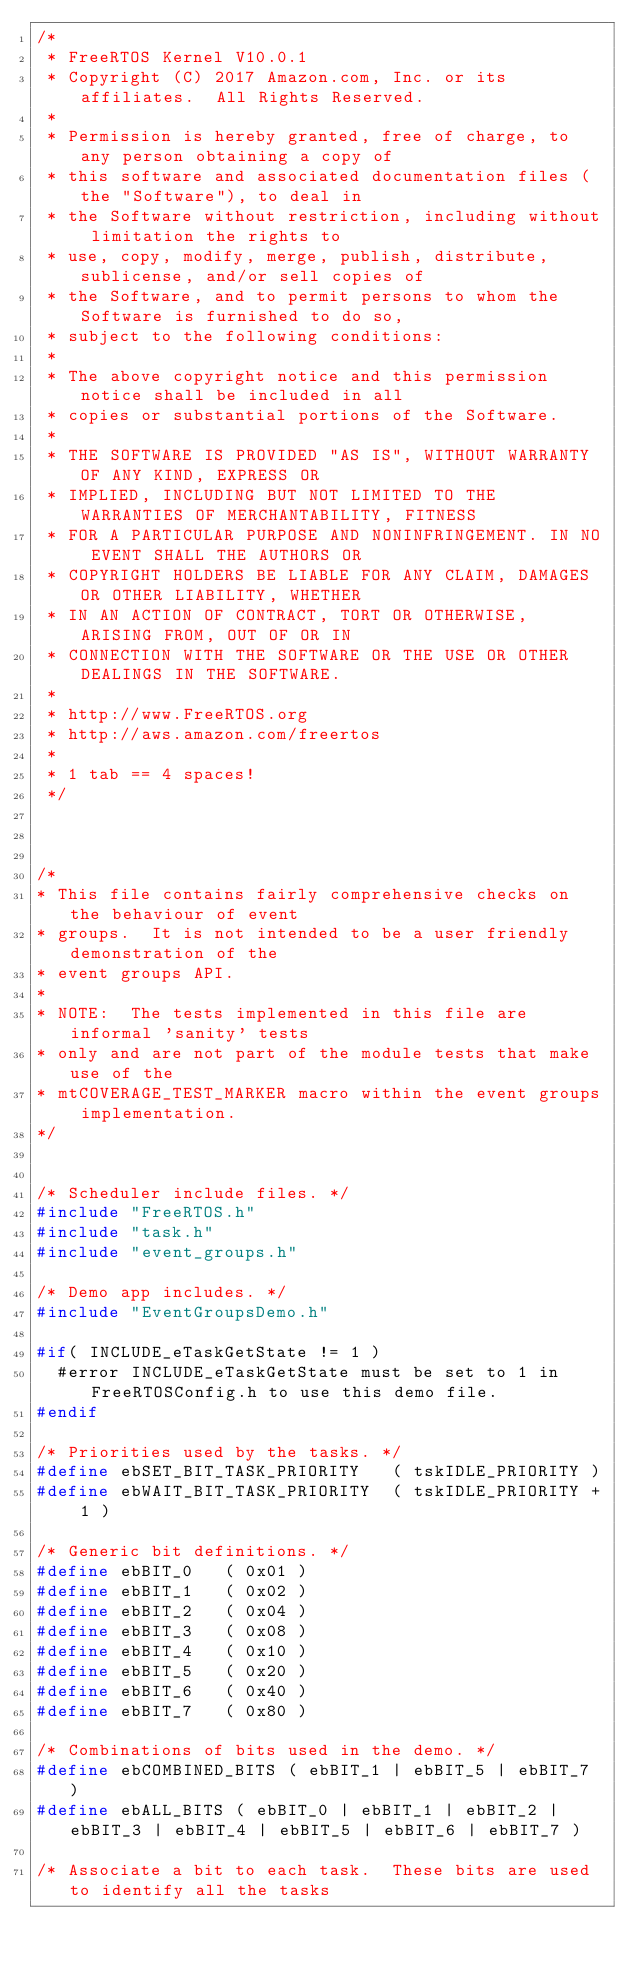Convert code to text. <code><loc_0><loc_0><loc_500><loc_500><_C_>/*
 * FreeRTOS Kernel V10.0.1
 * Copyright (C) 2017 Amazon.com, Inc. or its affiliates.  All Rights Reserved.
 *
 * Permission is hereby granted, free of charge, to any person obtaining a copy of
 * this software and associated documentation files (the "Software"), to deal in
 * the Software without restriction, including without limitation the rights to
 * use, copy, modify, merge, publish, distribute, sublicense, and/or sell copies of
 * the Software, and to permit persons to whom the Software is furnished to do so,
 * subject to the following conditions:
 *
 * The above copyright notice and this permission notice shall be included in all
 * copies or substantial portions of the Software.
 *
 * THE SOFTWARE IS PROVIDED "AS IS", WITHOUT WARRANTY OF ANY KIND, EXPRESS OR
 * IMPLIED, INCLUDING BUT NOT LIMITED TO THE WARRANTIES OF MERCHANTABILITY, FITNESS
 * FOR A PARTICULAR PURPOSE AND NONINFRINGEMENT. IN NO EVENT SHALL THE AUTHORS OR
 * COPYRIGHT HOLDERS BE LIABLE FOR ANY CLAIM, DAMAGES OR OTHER LIABILITY, WHETHER
 * IN AN ACTION OF CONTRACT, TORT OR OTHERWISE, ARISING FROM, OUT OF OR IN
 * CONNECTION WITH THE SOFTWARE OR THE USE OR OTHER DEALINGS IN THE SOFTWARE.
 *
 * http://www.FreeRTOS.org
 * http://aws.amazon.com/freertos
 *
 * 1 tab == 4 spaces!
 */



/*
* This file contains fairly comprehensive checks on the behaviour of event
* groups.  It is not intended to be a user friendly demonstration of the
* event groups API.
*
* NOTE:  The tests implemented in this file are informal 'sanity' tests
* only and are not part of the module tests that make use of the
* mtCOVERAGE_TEST_MARKER macro within the event groups implementation.
*/


/* Scheduler include files. */
#include "FreeRTOS.h"
#include "task.h"
#include "event_groups.h"

/* Demo app includes. */
#include "EventGroupsDemo.h"

#if( INCLUDE_eTaskGetState != 1 )
	#error INCLUDE_eTaskGetState must be set to 1 in FreeRTOSConfig.h to use this demo file.
#endif

/* Priorities used by the tasks. */
#define ebSET_BIT_TASK_PRIORITY		( tskIDLE_PRIORITY )
#define ebWAIT_BIT_TASK_PRIORITY	( tskIDLE_PRIORITY + 1 )

/* Generic bit definitions. */
#define ebBIT_0		( 0x01 )
#define ebBIT_1		( 0x02 )
#define ebBIT_2		( 0x04 )
#define ebBIT_3		( 0x08 )
#define ebBIT_4		( 0x10 )
#define ebBIT_5		( 0x20 )
#define ebBIT_6		( 0x40 )
#define ebBIT_7		( 0x80 )

/* Combinations of bits used in the demo. */
#define ebCOMBINED_BITS ( ebBIT_1 | ebBIT_5 | ebBIT_7 )
#define ebALL_BITS ( ebBIT_0 | ebBIT_1 | ebBIT_2 | ebBIT_3 | ebBIT_4 | ebBIT_5 | ebBIT_6 | ebBIT_7 )

/* Associate a bit to each task.  These bits are used to identify all the tasks</code> 